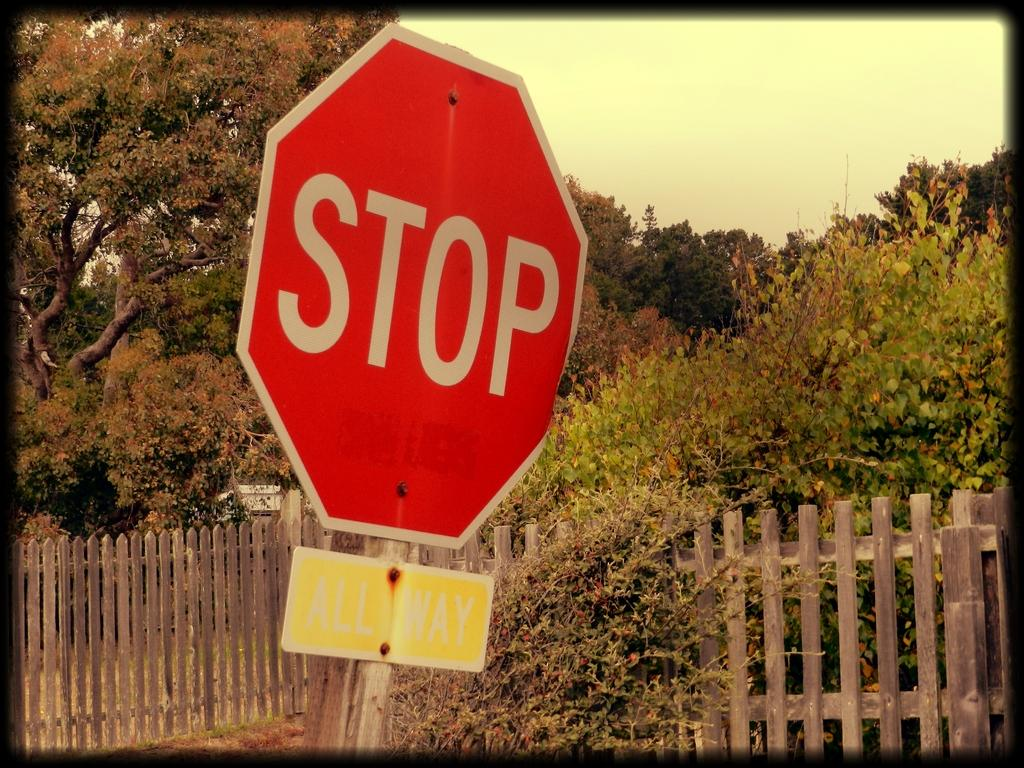<image>
Provide a brief description of the given image. The stop sign includes a message underneath that says all way to alert motorists every direction must stop. 